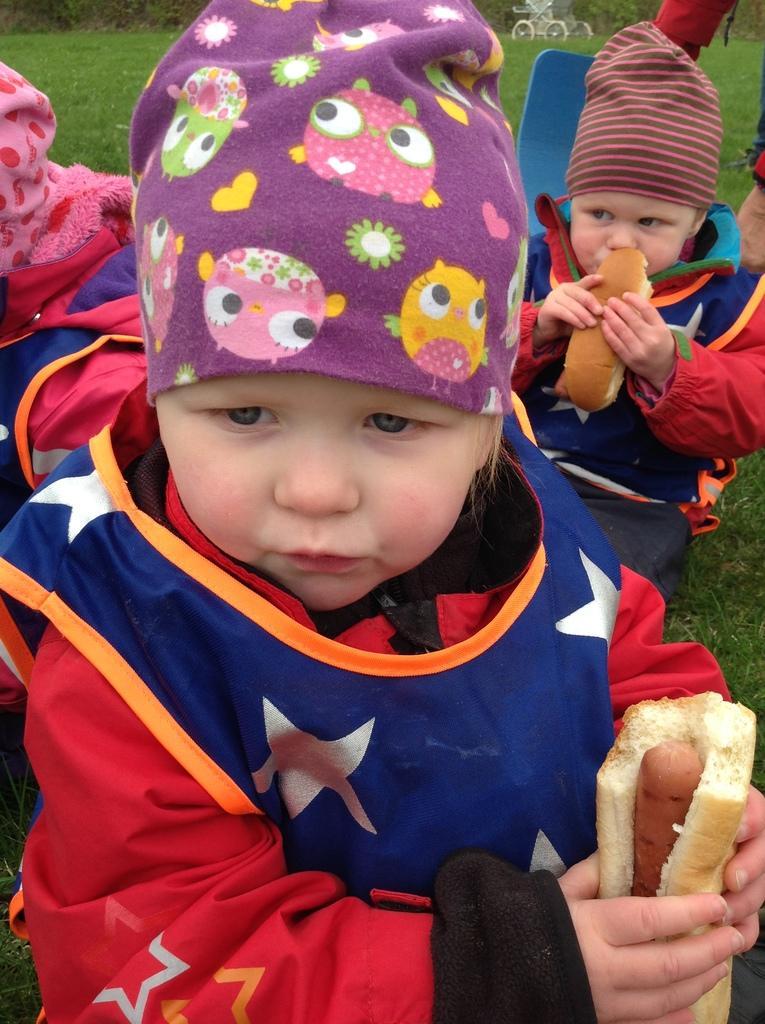Please provide a concise description of this image. There are children, it seems like they are eating and grassland in the background. 